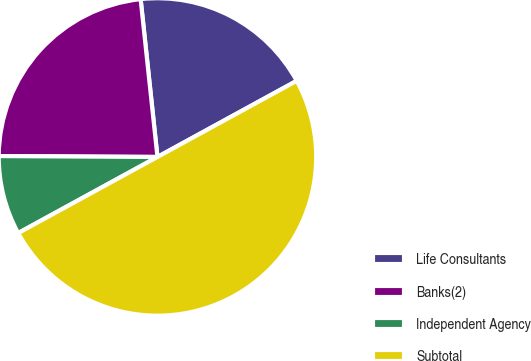<chart> <loc_0><loc_0><loc_500><loc_500><pie_chart><fcel>Life Consultants<fcel>Banks(2)<fcel>Independent Agency<fcel>Subtotal<nl><fcel>18.73%<fcel>23.22%<fcel>8.05%<fcel>50.0%<nl></chart> 